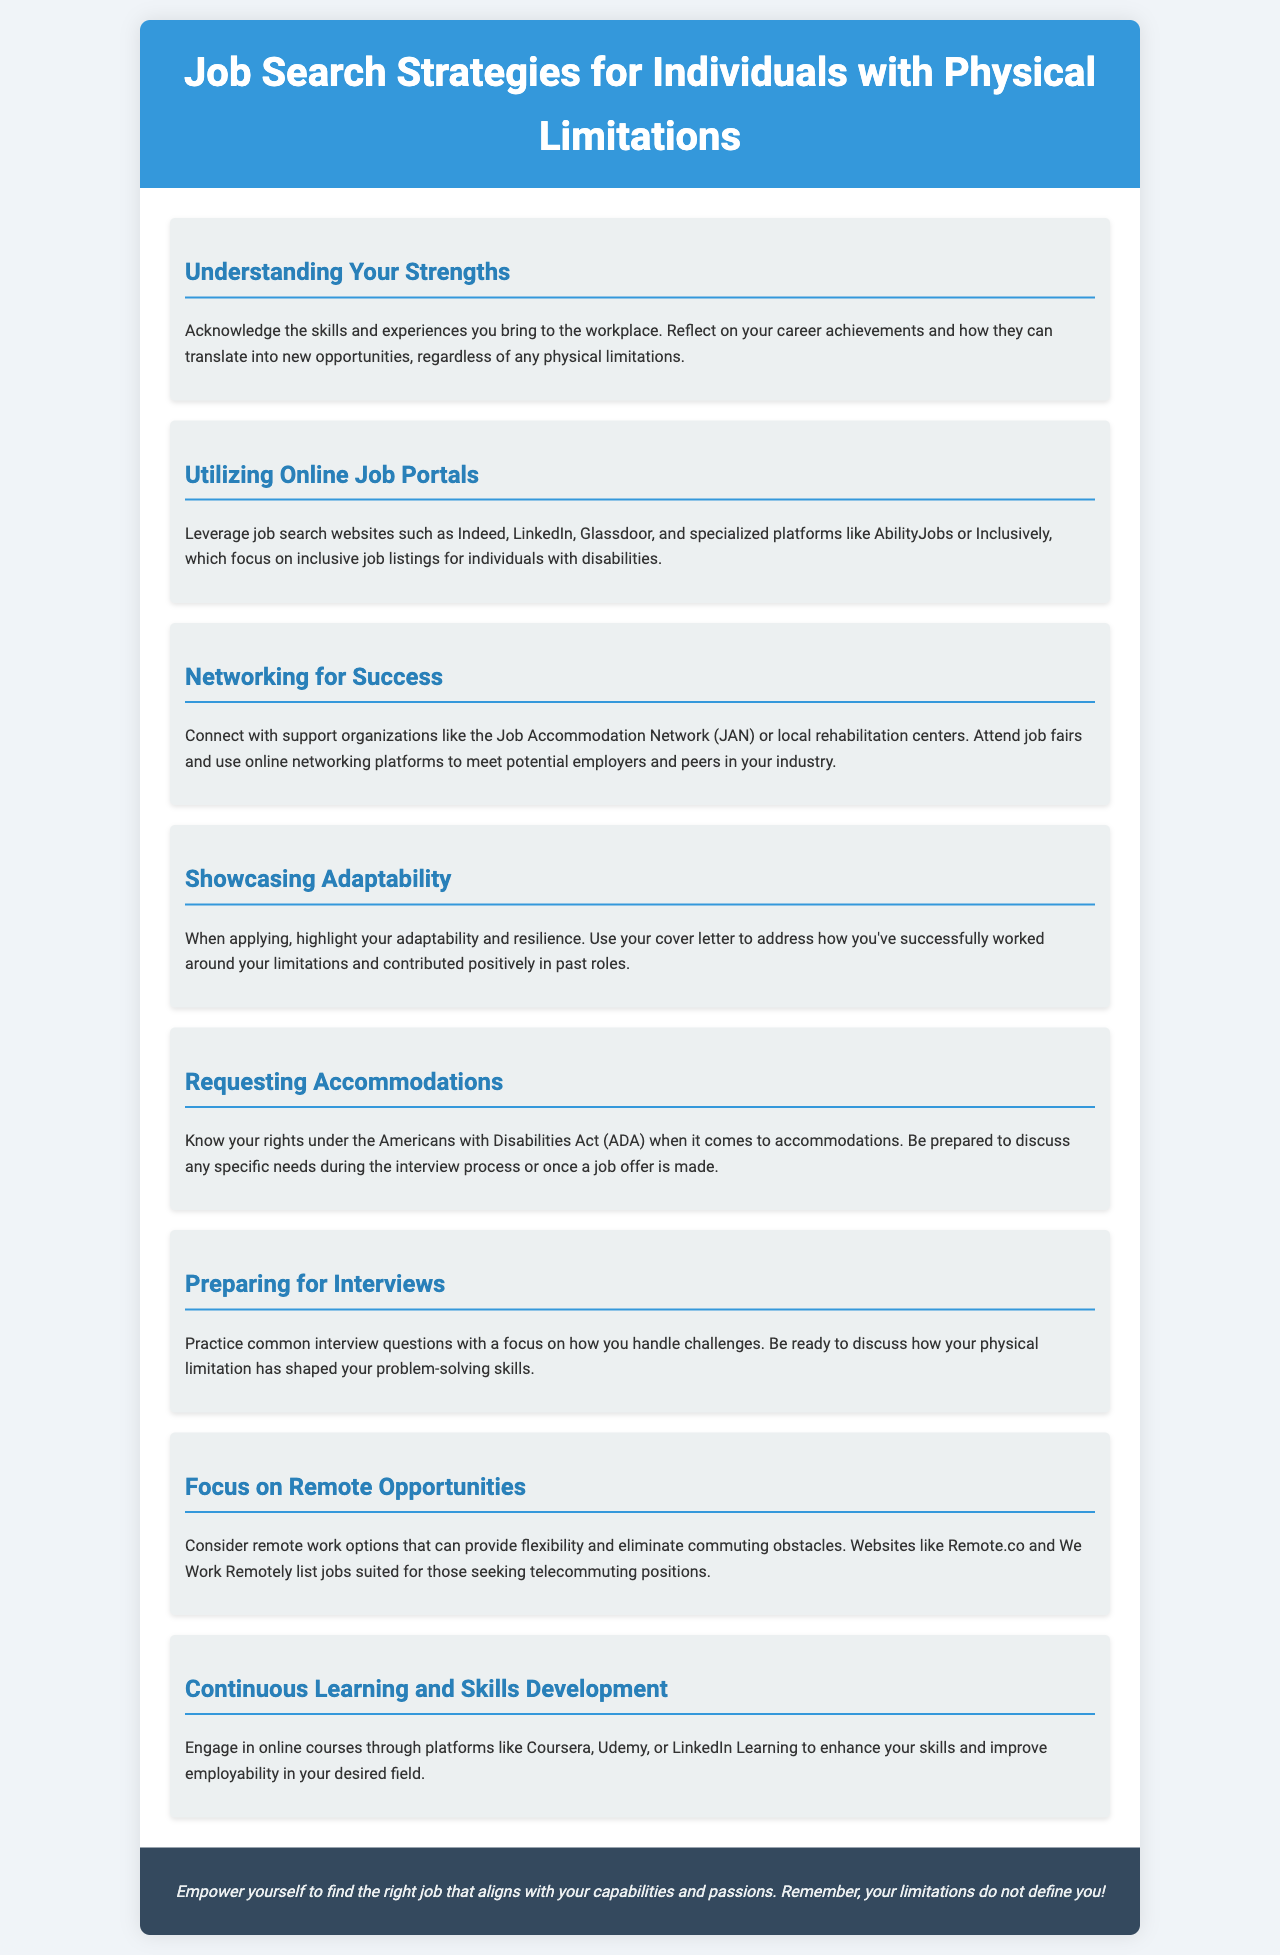What is the title of the brochure? The title of the brochure is prominently displayed in the header section of the document.
Answer: Job Search Strategies for Individuals with Physical Limitations What is one of the suggested online job portals mentioned? The document lists various job portals, and one example is found under the relevant section.
Answer: Indeed What should you highlight in your cover letter? The content advises on what to include in a cover letter to address specific needs related to physical limitations.
Answer: Adaptability and resilience Which act should you be familiar with regarding accommodations? The document references a specific act that protects individuals with disabilities in the workplace.
Answer: Americans with Disabilities Act (ADA) What is a recommended action for professional development? The text suggests a specific activity that can enhance skills for employability.
Answer: Engage in online courses Who can you connect with for networking according to the brochure? The document mentions organizations that can aid in networking efforts.
Answer: Job Accommodation Network (JAN) What type of job opportunities are suggested for flexibility? The document discusses job types that allow for working from home to better accommodate physical limitations.
Answer: Remote work options What platforms are mentioned for enhancing skills? The document lists several platforms for online learning aimed at skill enhancement.
Answer: Coursera, Udemy, LinkedIn Learning 